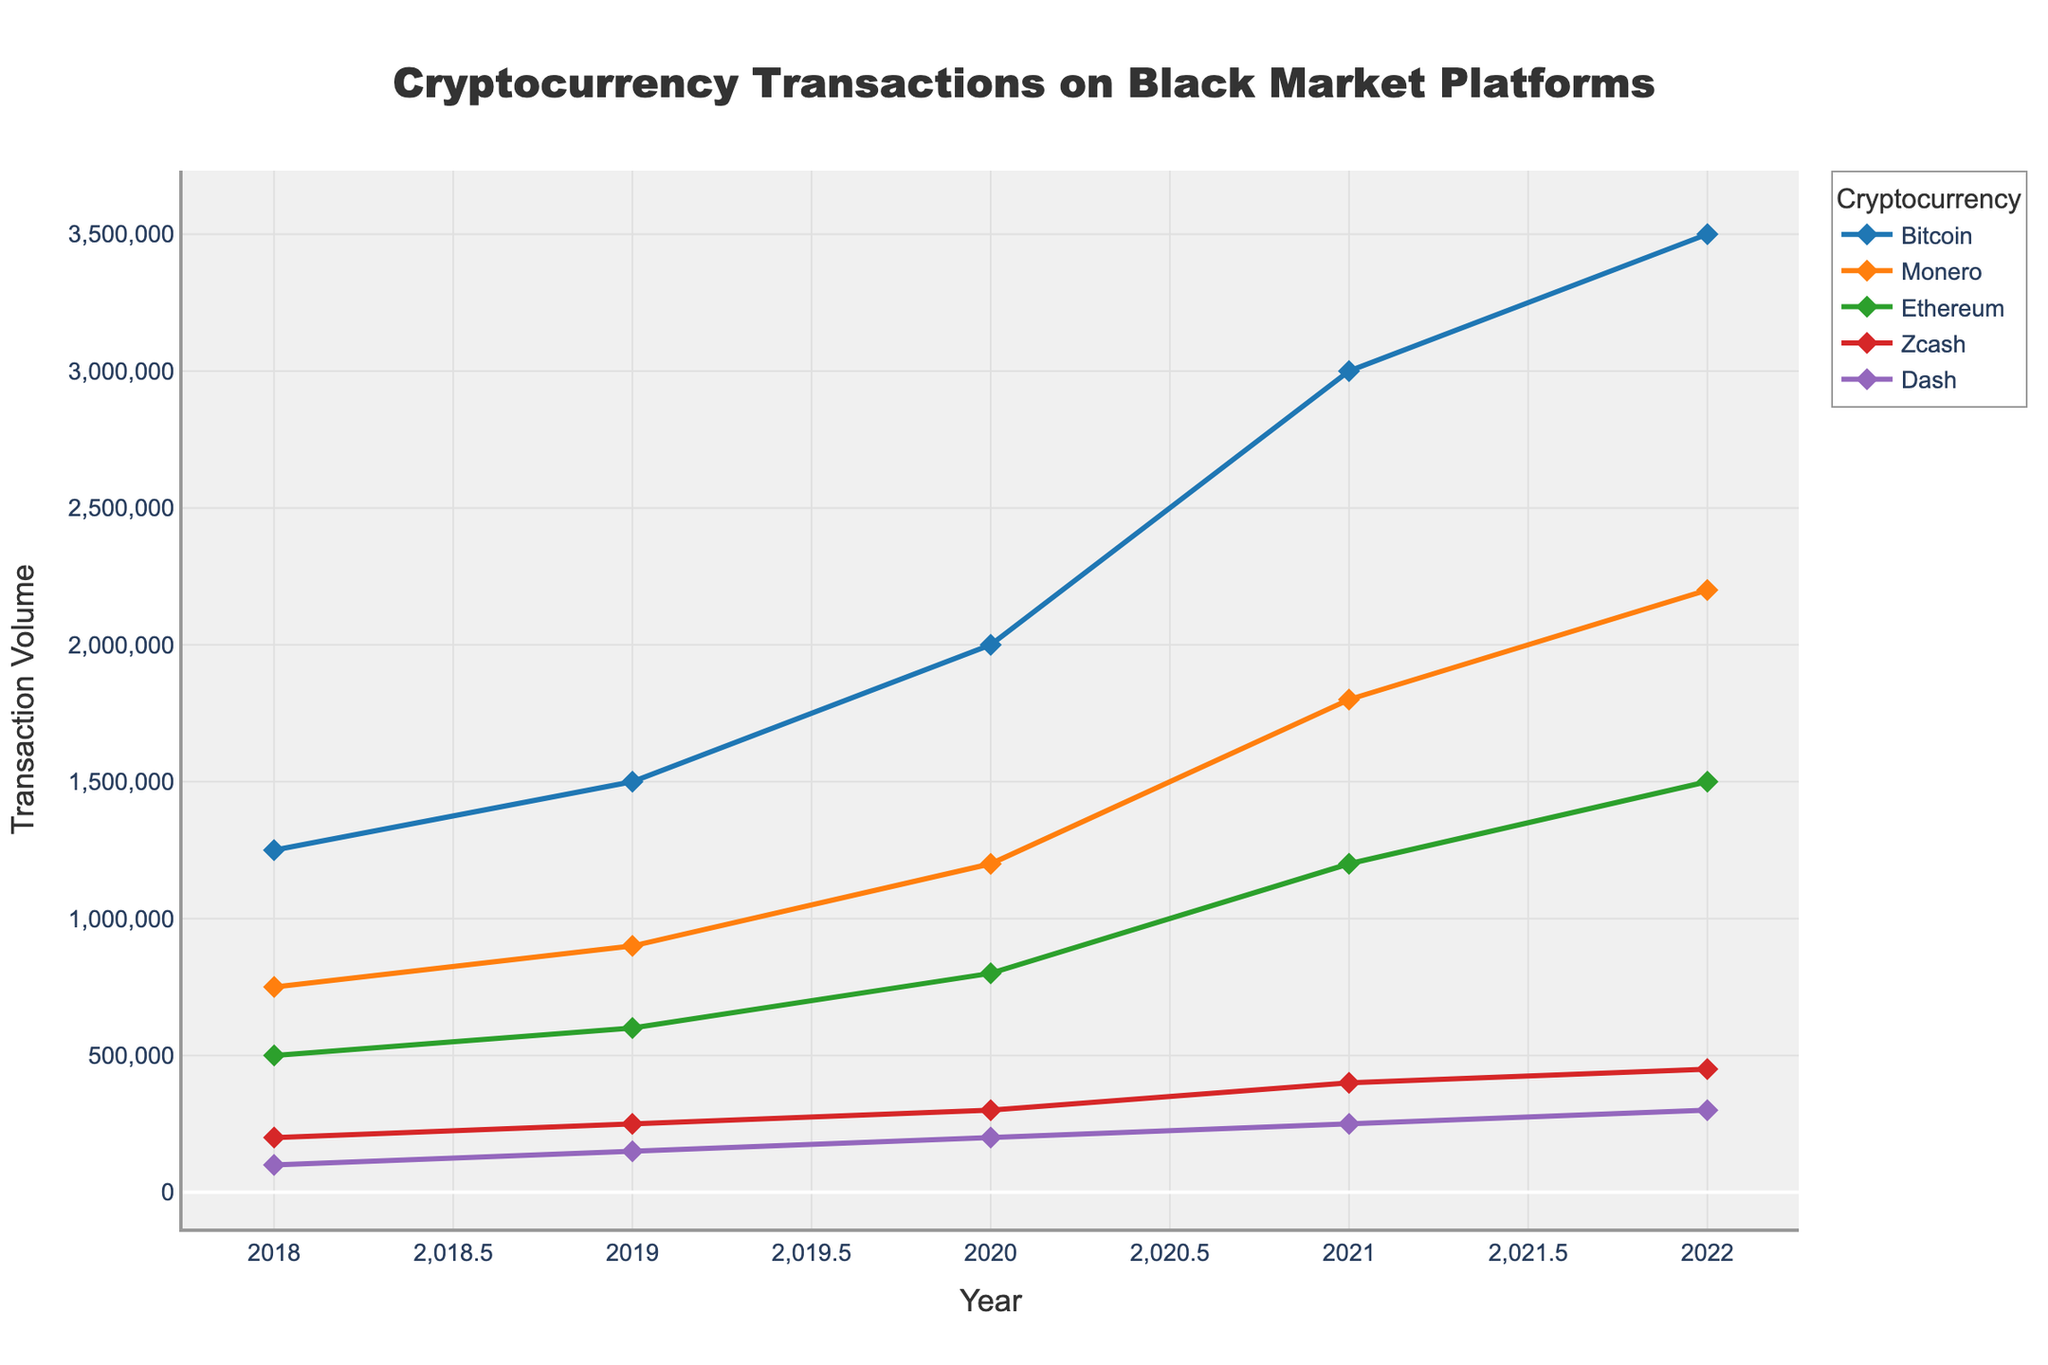What's the percentage increase in Bitcoin transactions from 2018 to 2022? To find the percentage increase, we use the formula: \[(Final Value - Initial Value) / Initial Value \times 100\]. For Bitcoin: \[(3,500,000 - 1,250,000) / 1,250,000 \times 100 = 180\]%
Answer: 180% Which cryptocurrency showed the highest increase in transaction volume between 2018 and 2022? By comparing the increase in transaction volume for each cryptocurrency, Bitcoin increased by 2,250,000, Monero increased by 1,450,000, Ethereum increased by 1,000,000, Zcash increased by 250,000, and Dash increased by 200,000. Bitcoin shows the highest increase.
Answer: Bitcoin In which year did Monero transactions surpass the 1,000,000 mark? By examining the Monero transaction line on the chart, we see that it surpassed the 1,000,000 mark in the year 2020.
Answer: 2020 Between which consecutive years did Ethereum show the highest growth rate? The growth rates for Ethereum are calculated between consecutive years: \[(600,000 - 500,000) / 500,000 \times 100 = 20\]% for 2018-2019, \[(800,000 - 600,000) / 600,000 \times 100 = 33.3\]% for 2019-2020, \[(1,200,000 - 800,000) / 800,000 \times 100 = 50\]% for 2020-2021, \[(1,500,000 - 1,200,000) / 1,200,000 \times 100 = 25\]% for 2021-2022. The highest growth rate is 50%, which is between 2020 and 2021.
Answer: 2020-2021 Which year had the smallest difference in transaction volume between Bitcoin and Monero? The differences in transaction volumes between Bitcoin and Monero for each year are: \(1250000 - 750000 = 500000\) for 2018, \(1500000 - 900000 = 600000\) for 2019, \(2000000 - 1200000 = 800000\) for 2020, \(3000000 - 1800000 = 1200000\) for 2021, and \(3500000 - 2200000 = 1300000\) for 2022. The smallest difference is 500,000, which is in the year 2018.
Answer: 2018 On average, how many Dash transactions occurred per year over the observed period? To find the average: \[(100,000 + 150,000 + 200,000 + 250,000 + 300,000) / 5 = 200,000\].
Answer: 200,000 Which cryptocurrency had the most consistent growth pattern across all years? By visually assessing the lines, all cryptocurrencies show growth but Zcash has a relatively consistent increment each year without sharp increases.
Answer: Zcash Looking at the trend lines, which cryptocurrency seems to be the most volatile in its transaction volume changes? By evaluating the steepness and fluctuations of the lines, Monero shows steeper increases and sharper changes, indicating higher volatility.
Answer: Monero 